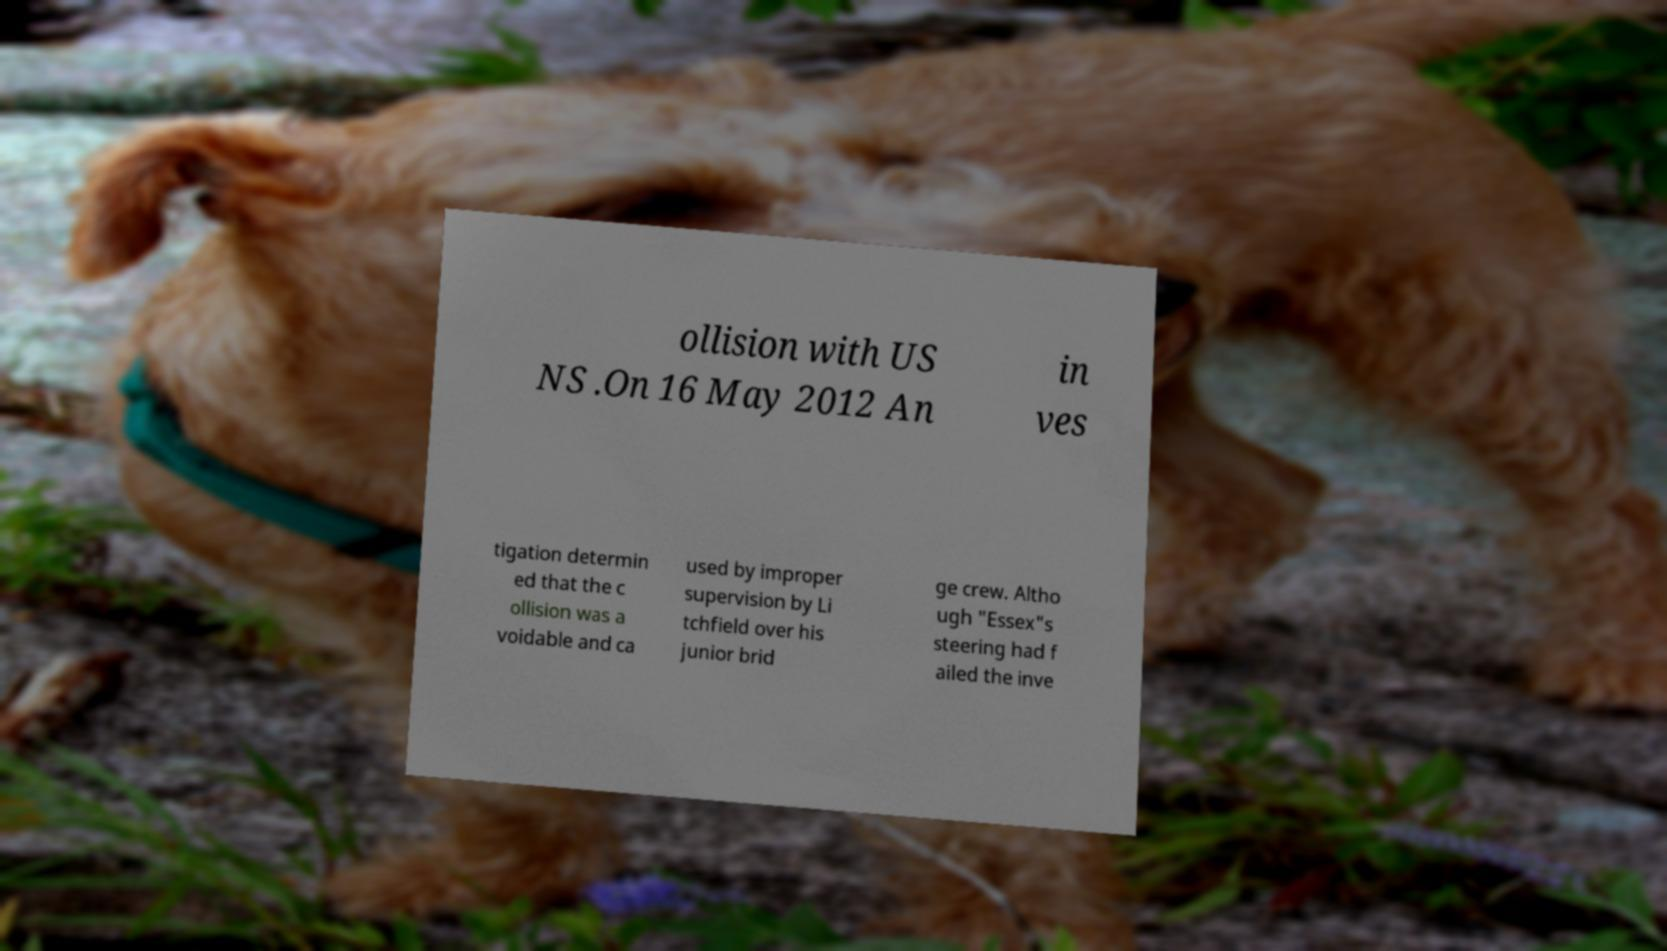Could you extract and type out the text from this image? ollision with US NS .On 16 May 2012 An in ves tigation determin ed that the c ollision was a voidable and ca used by improper supervision by Li tchfield over his junior brid ge crew. Altho ugh "Essex"s steering had f ailed the inve 